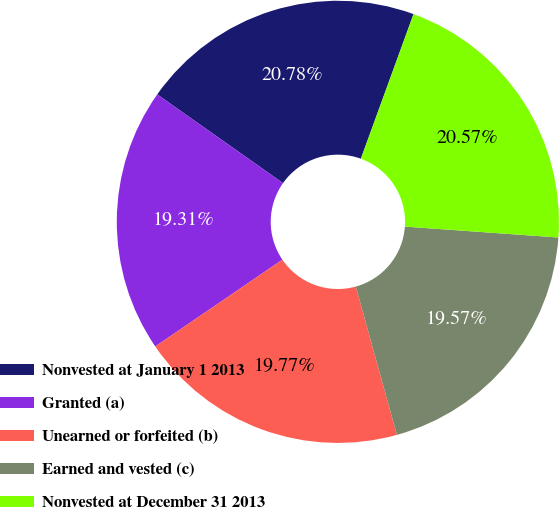Convert chart. <chart><loc_0><loc_0><loc_500><loc_500><pie_chart><fcel>Nonvested at January 1 2013<fcel>Granted (a)<fcel>Unearned or forfeited (b)<fcel>Earned and vested (c)<fcel>Nonvested at December 31 2013<nl><fcel>20.78%<fcel>19.31%<fcel>19.77%<fcel>19.57%<fcel>20.57%<nl></chart> 